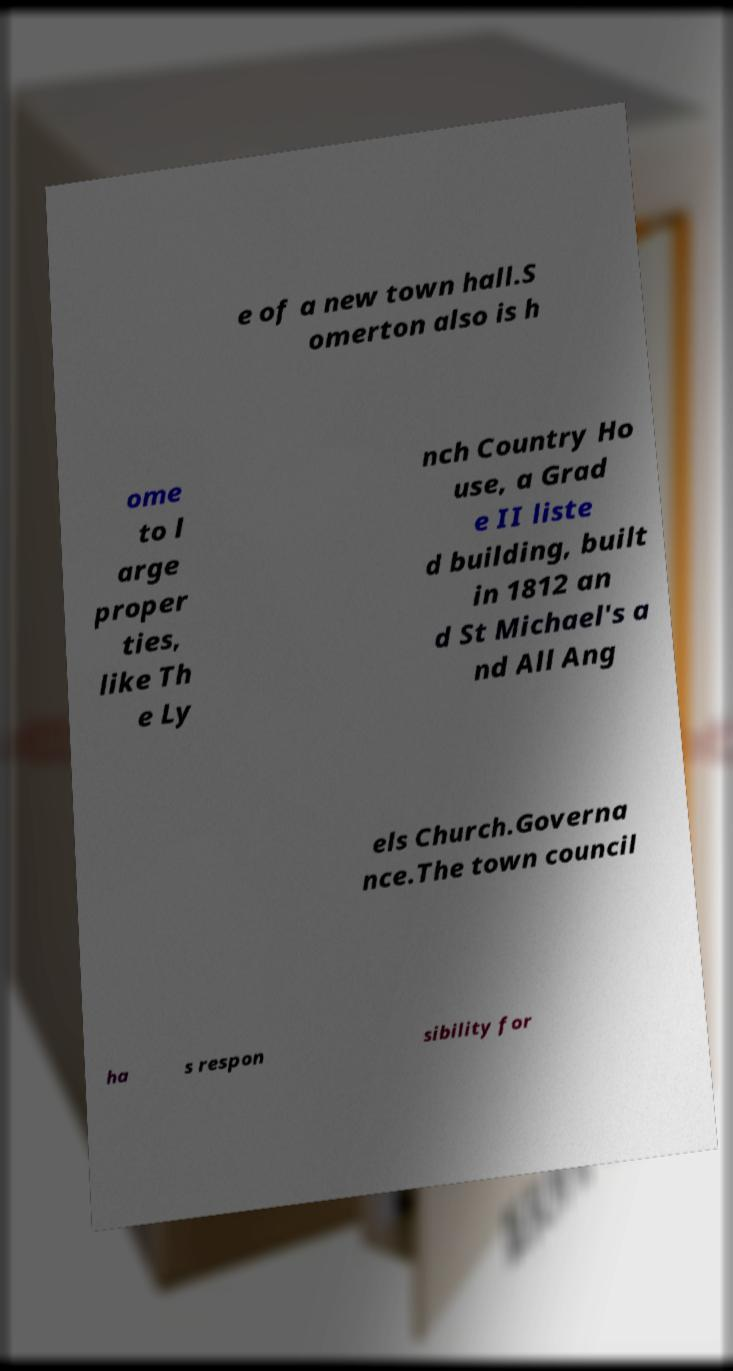Please identify and transcribe the text found in this image. e of a new town hall.S omerton also is h ome to l arge proper ties, like Th e Ly nch Country Ho use, a Grad e II liste d building, built in 1812 an d St Michael's a nd All Ang els Church.Governa nce.The town council ha s respon sibility for 